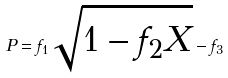Convert formula to latex. <formula><loc_0><loc_0><loc_500><loc_500>P = f _ { 1 } \sqrt { 1 - f _ { 2 } X } - f _ { 3 }</formula> 